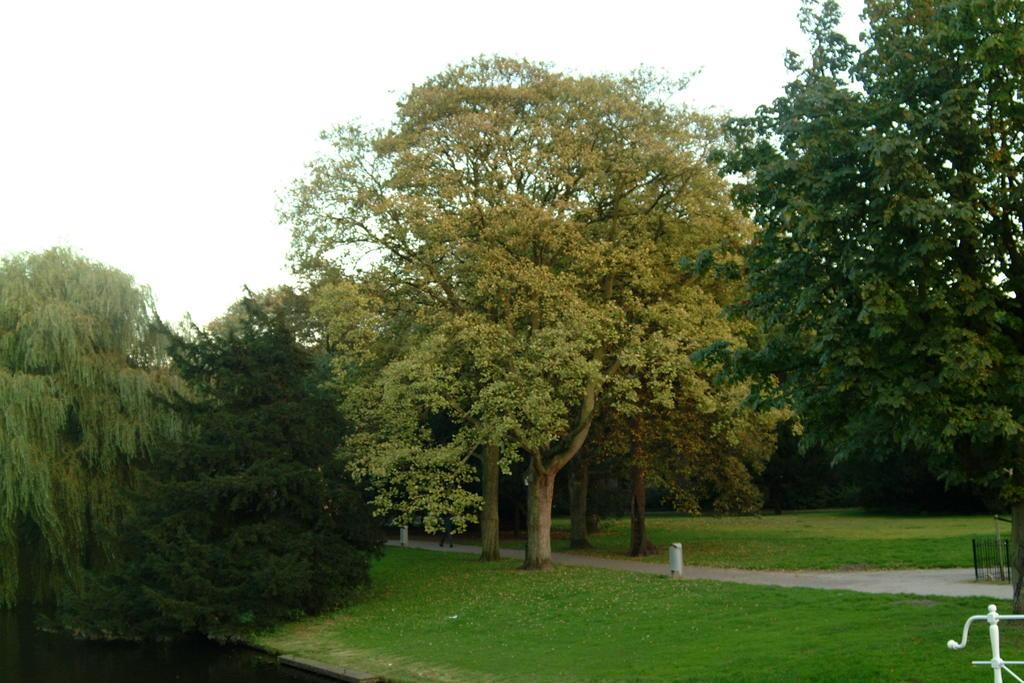What type of vegetation can be seen in the image? There is a group of trees and grass in the image. What can be used to walk on in the image? There is a pathway in the image that can be used for walking. What is the boundary in the image? There is a fence in the image that serves as a boundary. What are the metal structures in the image? There are metal poles in the image. What is visible in the sky in the image? The sky is visible in the image and appears cloudy. Who made the request for a suit in the image? There is no mention of a suit or a request in the image. What type of joke can be seen in the image? There is no joke present in the image. 